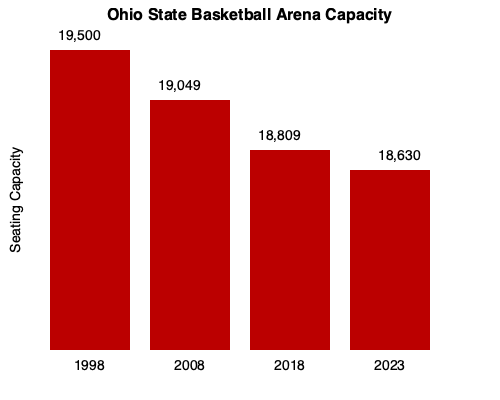Based on the bar chart showing Ohio State's basketball arena seating capacity over the years, what has been the overall trend in capacity from 1998 to 2023, and by approximately what percentage has the capacity decreased during this period? To answer this question, we need to analyze the data presented in the bar chart and perform some calculations:

1. Identify the trend:
   The bar heights decrease from left to right, indicating a decreasing trend in seating capacity from 1998 to 2023.

2. Find the capacities for 1998 and 2023:
   1998 capacity: 19,500
   2023 capacity: 18,630

3. Calculate the total decrease in capacity:
   $19,500 - 18,630 = 870$ seats

4. Calculate the percentage decrease:
   Percentage decrease = (Decrease / Original Value) × 100
   $\frac{870}{19,500} \times 100 = 4.46\%$

5. Round to the nearest whole percentage:
   4.46% rounds to 4%

Therefore, the overall trend in Ohio State's basketball arena seating capacity from 1998 to 2023 has been a decrease, with the capacity reducing by approximately 4% during this period.
Answer: Decreasing trend, approximately 4% decrease 